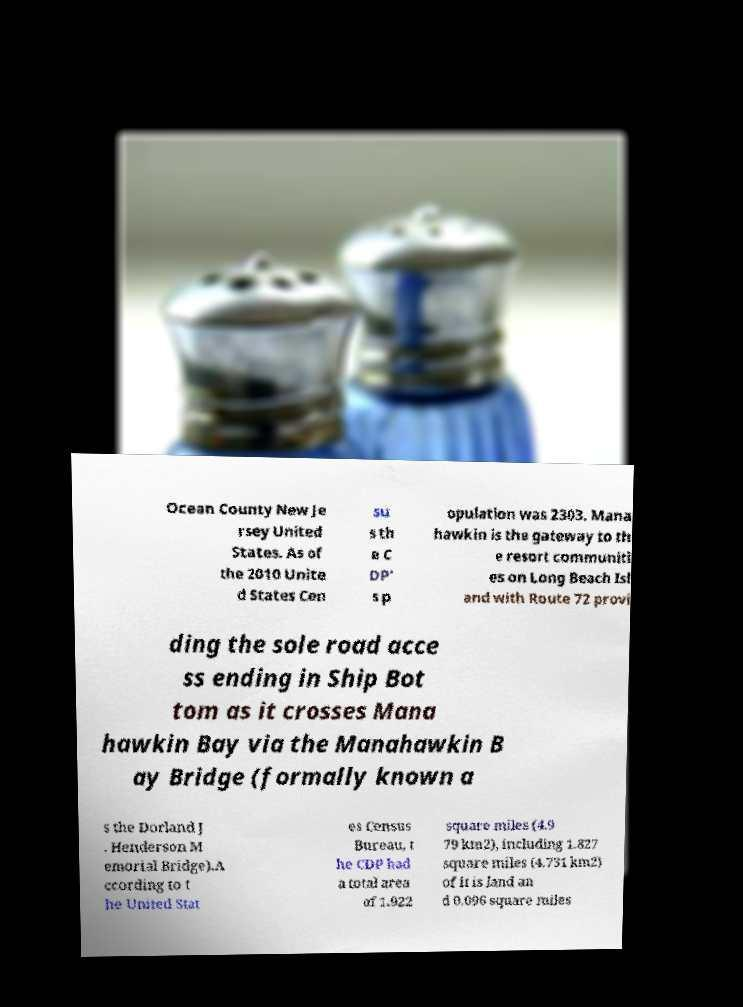Please identify and transcribe the text found in this image. Ocean County New Je rsey United States. As of the 2010 Unite d States Cen su s th e C DP' s p opulation was 2303. Mana hawkin is the gateway to th e resort communiti es on Long Beach Isl and with Route 72 provi ding the sole road acce ss ending in Ship Bot tom as it crosses Mana hawkin Bay via the Manahawkin B ay Bridge (formally known a s the Dorland J . Henderson M emorial Bridge).A ccording to t he United Stat es Census Bureau, t he CDP had a total area of 1.922 square miles (4.9 79 km2), including 1.827 square miles (4.731 km2) of it is land an d 0.096 square miles 